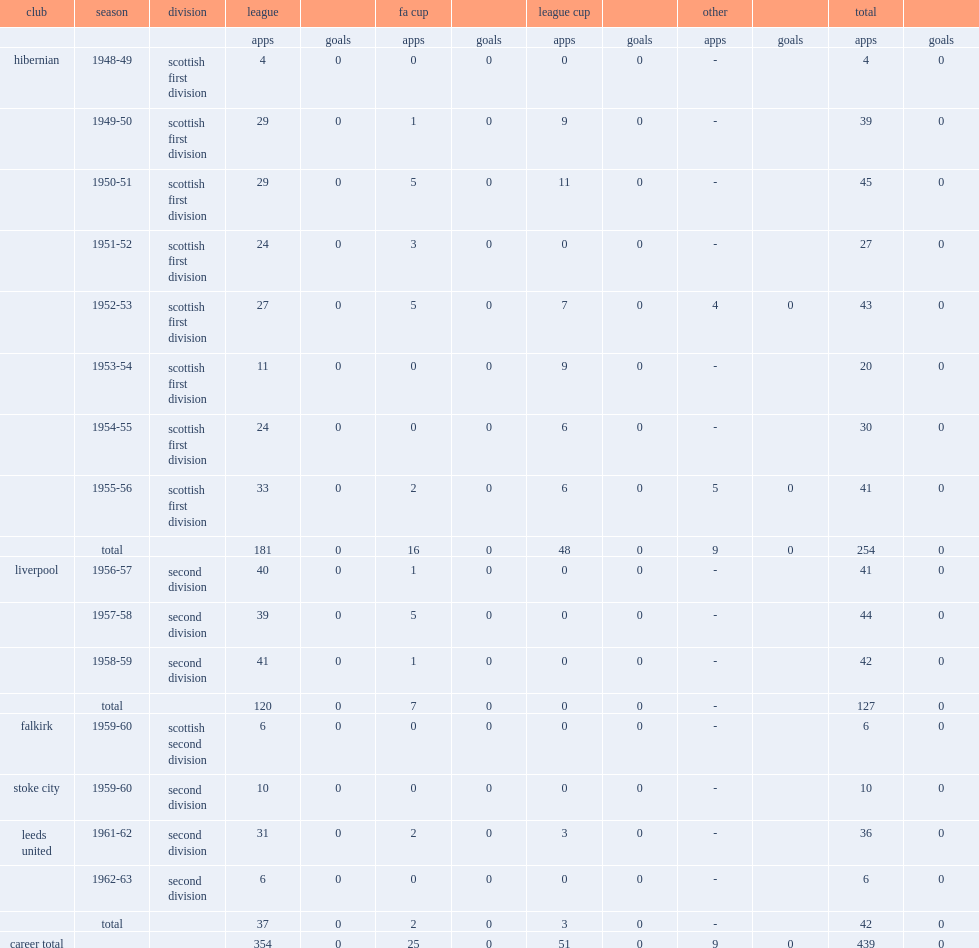How many appearances did younger spend three years in liverpool, making a total of? 127. 